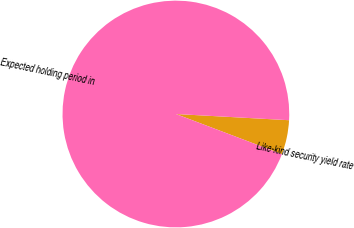<chart> <loc_0><loc_0><loc_500><loc_500><pie_chart><fcel>Like-kind security yield rate<fcel>Expected holding period in<nl><fcel>4.89%<fcel>95.11%<nl></chart> 